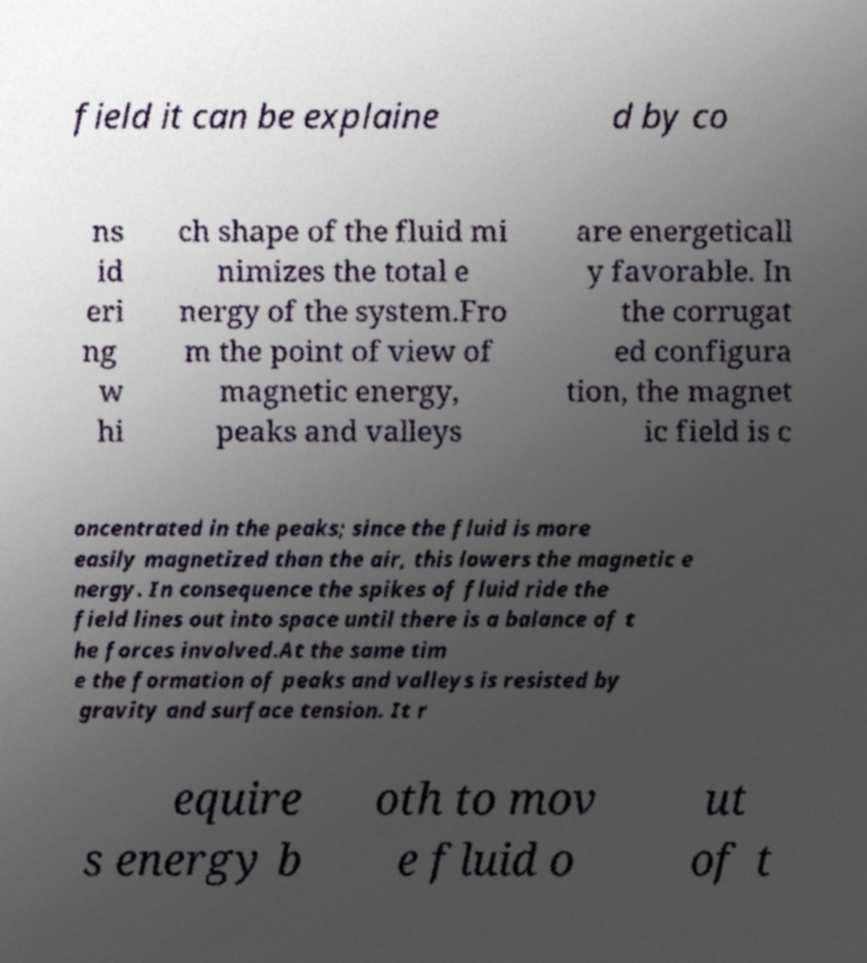Can you read and provide the text displayed in the image?This photo seems to have some interesting text. Can you extract and type it out for me? field it can be explaine d by co ns id eri ng w hi ch shape of the fluid mi nimizes the total e nergy of the system.Fro m the point of view of magnetic energy, peaks and valleys are energeticall y favorable. In the corrugat ed configura tion, the magnet ic field is c oncentrated in the peaks; since the fluid is more easily magnetized than the air, this lowers the magnetic e nergy. In consequence the spikes of fluid ride the field lines out into space until there is a balance of t he forces involved.At the same tim e the formation of peaks and valleys is resisted by gravity and surface tension. It r equire s energy b oth to mov e fluid o ut of t 